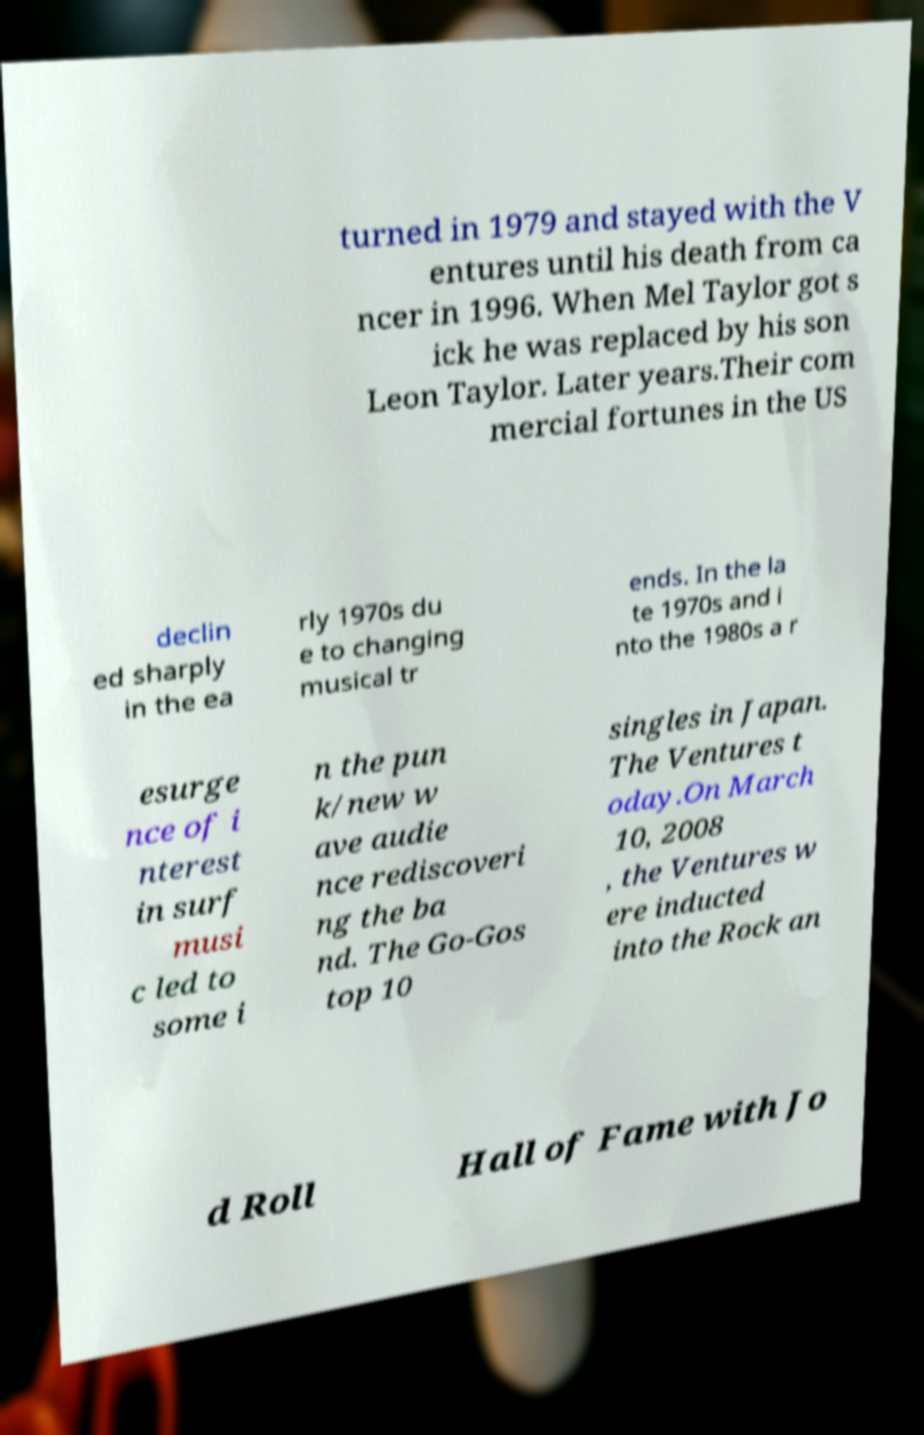For documentation purposes, I need the text within this image transcribed. Could you provide that? turned in 1979 and stayed with the V entures until his death from ca ncer in 1996. When Mel Taylor got s ick he was replaced by his son Leon Taylor. Later years.Their com mercial fortunes in the US declin ed sharply in the ea rly 1970s du e to changing musical tr ends. In the la te 1970s and i nto the 1980s a r esurge nce of i nterest in surf musi c led to some i n the pun k/new w ave audie nce rediscoveri ng the ba nd. The Go-Gos top 10 singles in Japan. The Ventures t oday.On March 10, 2008 , the Ventures w ere inducted into the Rock an d Roll Hall of Fame with Jo 